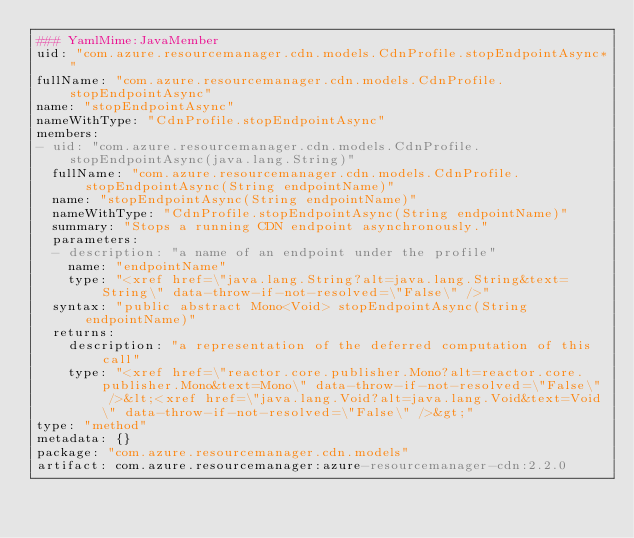<code> <loc_0><loc_0><loc_500><loc_500><_YAML_>### YamlMime:JavaMember
uid: "com.azure.resourcemanager.cdn.models.CdnProfile.stopEndpointAsync*"
fullName: "com.azure.resourcemanager.cdn.models.CdnProfile.stopEndpointAsync"
name: "stopEndpointAsync"
nameWithType: "CdnProfile.stopEndpointAsync"
members:
- uid: "com.azure.resourcemanager.cdn.models.CdnProfile.stopEndpointAsync(java.lang.String)"
  fullName: "com.azure.resourcemanager.cdn.models.CdnProfile.stopEndpointAsync(String endpointName)"
  name: "stopEndpointAsync(String endpointName)"
  nameWithType: "CdnProfile.stopEndpointAsync(String endpointName)"
  summary: "Stops a running CDN endpoint asynchronously."
  parameters:
  - description: "a name of an endpoint under the profile"
    name: "endpointName"
    type: "<xref href=\"java.lang.String?alt=java.lang.String&text=String\" data-throw-if-not-resolved=\"False\" />"
  syntax: "public abstract Mono<Void> stopEndpointAsync(String endpointName)"
  returns:
    description: "a representation of the deferred computation of this call"
    type: "<xref href=\"reactor.core.publisher.Mono?alt=reactor.core.publisher.Mono&text=Mono\" data-throw-if-not-resolved=\"False\" />&lt;<xref href=\"java.lang.Void?alt=java.lang.Void&text=Void\" data-throw-if-not-resolved=\"False\" />&gt;"
type: "method"
metadata: {}
package: "com.azure.resourcemanager.cdn.models"
artifact: com.azure.resourcemanager:azure-resourcemanager-cdn:2.2.0
</code> 